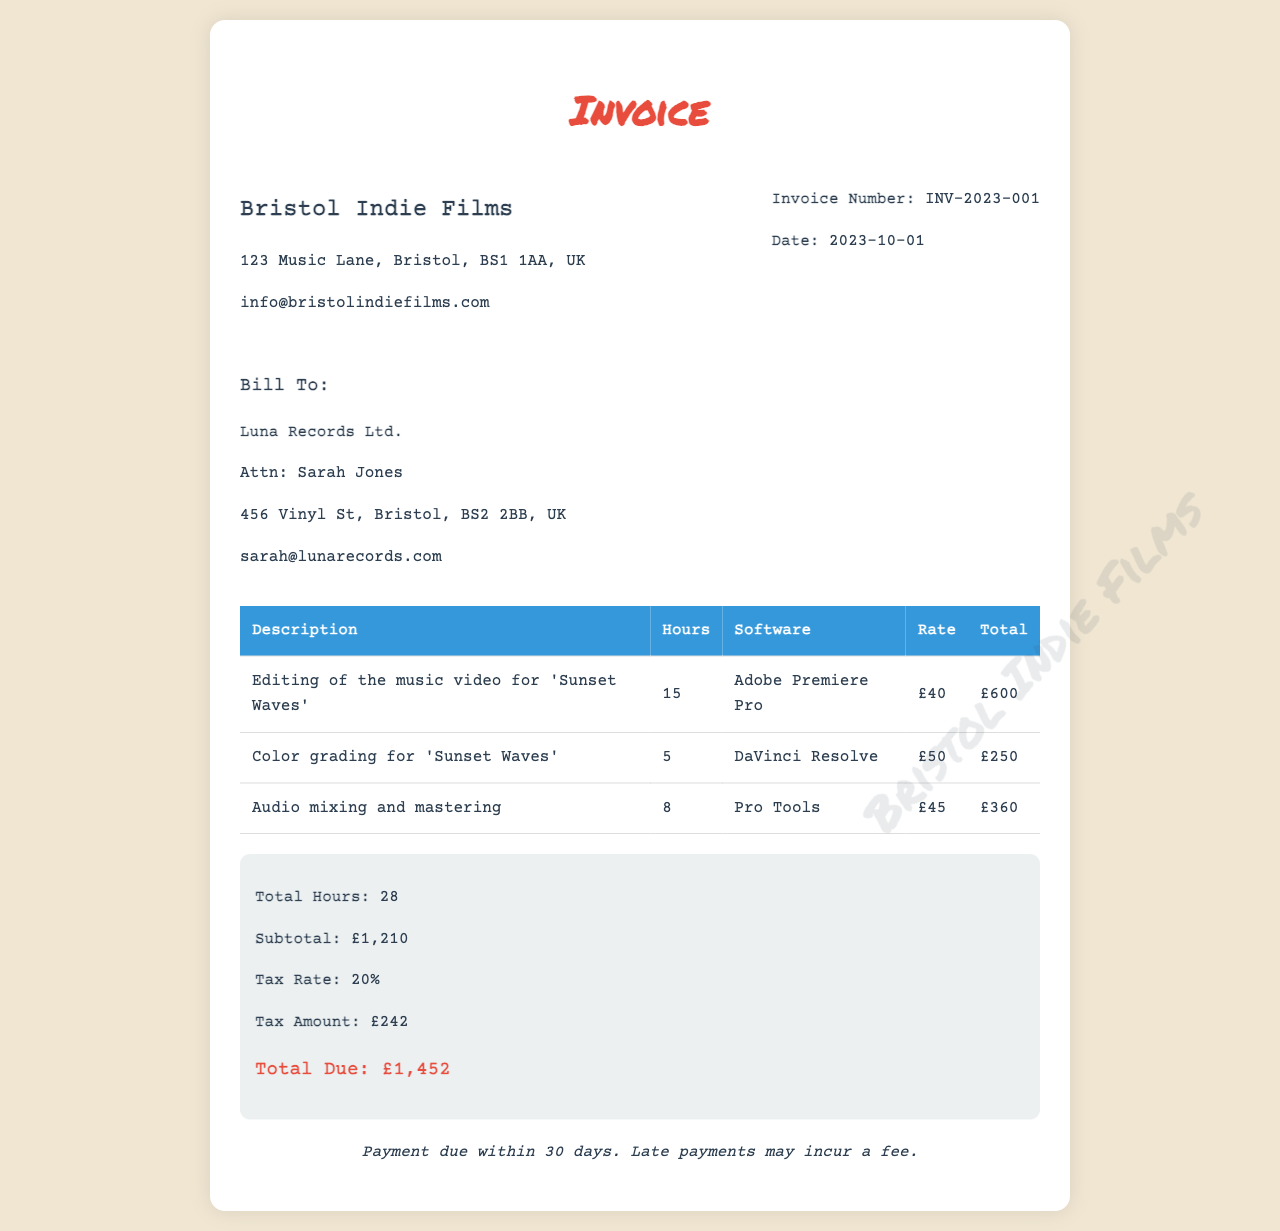What is the invoice number? The invoice number is stated at the top of the document, which identifies this specific transaction.
Answer: INV-2023-001 Who is the client? The client is mentioned in the "Bill To" section, specifying the recipient of the invoice.
Answer: Luna Records Ltd How many hours were spent on editing? The hours worked on editing are detailed in the first row of the table.
Answer: 15 What is the total due amount? The total due is summarized at the bottom of the document, showing the final amount payable.
Answer: £1,452 What software was used for color grading? The software used for color grading is specified in the corresponding row of the table.
Answer: DaVinci Resolve What is the subtotal before tax? The subtotal represents the total amount before tax calculations, indicated in the summary section.
Answer: £1,210 How much was charged for audio mixing and mastering? The total cost for audio mixing and mastering is shown in the last row of the table.
Answer: £360 What is the tax rate applied? The tax rate is listed in the summary section of the invoice.
Answer: 20% How many total hours were worked? The total hours are presented in the summary section, reflecting the sum of all billed hours.
Answer: 28 